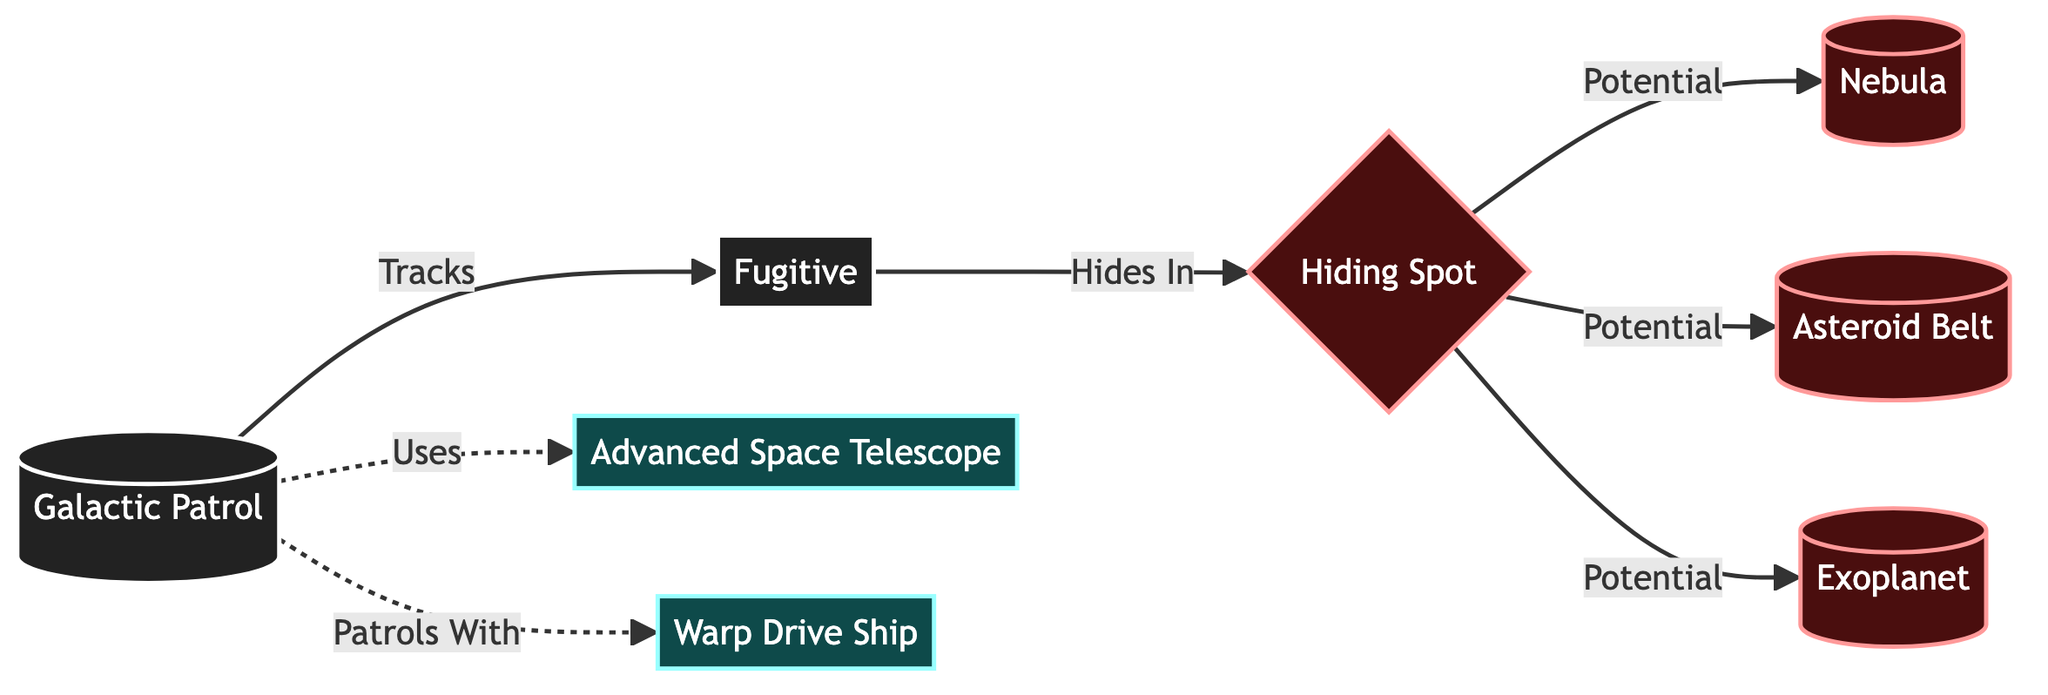What are the nodes connected to the "Hiding Spot"? The "Hiding Spot" node (3) has edges leading to three different nodes: "Nebula" (4), "Asteroid Belt" (5), and "Exoplanet" (6), depicting potential hiding places.
Answer: Nebula, Asteroid Belt, Exoplanet How many nodes are classified as "tech"? There are two nodes in the diagram classified as "tech": "Advanced Space Telescope" (7) and "Warp Drive Ship" (8).
Answer: 2 What relationship does the "Galactic Patrol" have with the "Fugitive"? The "Galactic Patrol" (1) has a directed edge to the "Fugitive" (2) indicating that it tracks the fugitive.
Answer: Tracks Which node represents a possible hiding place? The nodes connected to "Hiding Spot" (3) all represent potential hiding places, specifically "Nebula" (4), "Asteroid Belt" (5), and "Exoplanet" (6).
Answer: Nebula, Asteroid Belt, Exoplanet What technology is used by the "Galactic Patrol"? The "Galactic Patrol" (1) uses "Advanced Space Telescope" (7) for tracking, as indicated by the dashed line connecting the two.
Answer: Advanced Space Telescope What is the relationship between "Warp Drive Ship" and "Galactic Patrol"? The "Warp Drive Ship" (8) is associated with "Galactic Patrol" (1) through a dashed edge showing that the patrols with this technology.
Answer: Patrols With Which nodes are specifically identified as "hideout"? The "Hiding Spot" (3), "Nebula" (4), "Asteroid Belt" (5), and "Exoplanet" (6) are all classified under the "hideout" category.
Answer: Hiding Spot, Nebula, Asteroid Belt, Exoplanet What is the source of tracking for the "Fugitive"? The source of tracking for the "Fugitive" (2) comes from the "Galactic Patrol" (1), as indicated by the direct edge from the patrol to the fugitive.
Answer: Galactic Patrol How many potential hiding spots are there? There are three potential hiding spots listed under the "Hiding Spot" node: "Nebula" (4), "Asteroid Belt" (5), and "Exoplanet" (6), totaling three.
Answer: 3 